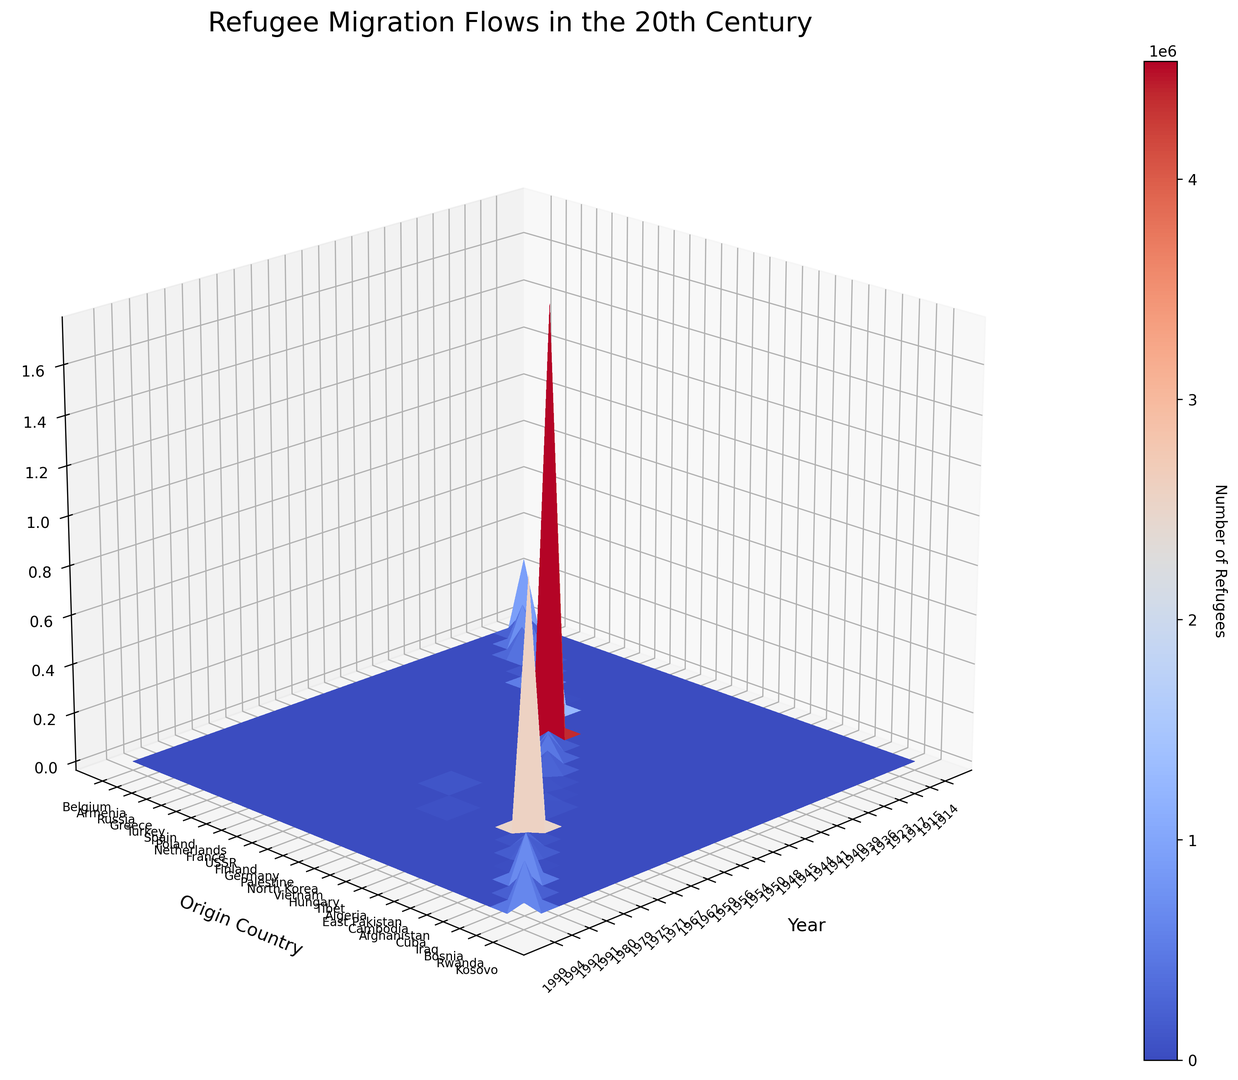What year shows the highest peak for refugee migration from "Germany"? By observing the Z-axis values corresponding to the "Germany" row in the 3D surface plot, identify which year among the x-axis labels has the highest peak. In this case, Germany in 1945 has the highest Z-axis value for the number of refugees.
Answer: 1945 Which origin country has the highest total number of refugees over all years? Sum the refugee numbers for each origin country by visually estimating the surface heights (Z-values) for each origin country across all years. Compare these sums across all origin countries to determine the highest total. "Germany" consistently shows high peaks in 1945.
Answer: Germany How does the refugee count from "Palestine" in the late 1940s compare to that from "Vietnam" in the mid-1970s? Check the Z-axis values for Palestine in the late 1940s (1948 specifically) and Vietnam in the mid-1970s (1975 specifically). Compare the relative heights of the surface plots at these points. Palestine has peaks around 1948, and Vietnam has significant peaks around 1975.
Answer: Palestine in 1948 is higher What is the difference in the number of refugees between "Germany" in 1945 and "East Pakistan" in 1971? Look at the Z-axis (height) values for Germany in 1945 and East Pakistan in 1971. Subtract the 1971 value from the 1945 value to calculate the difference. Germany in 1945 has a peak of 12,000,000+4,000,000+1,500,000=17,500,000; East Pakistan in 1971 has 10,000,000.
Answer: 7,500,000 Which year saw a significant refugee migration from "Spain"? Identify the peaks in the Z-axis values on the surface plot for the "Spain" row and match it with the corresponding year on the x-axis label. Spain shows peaks around 1936.
Answer: 1936 